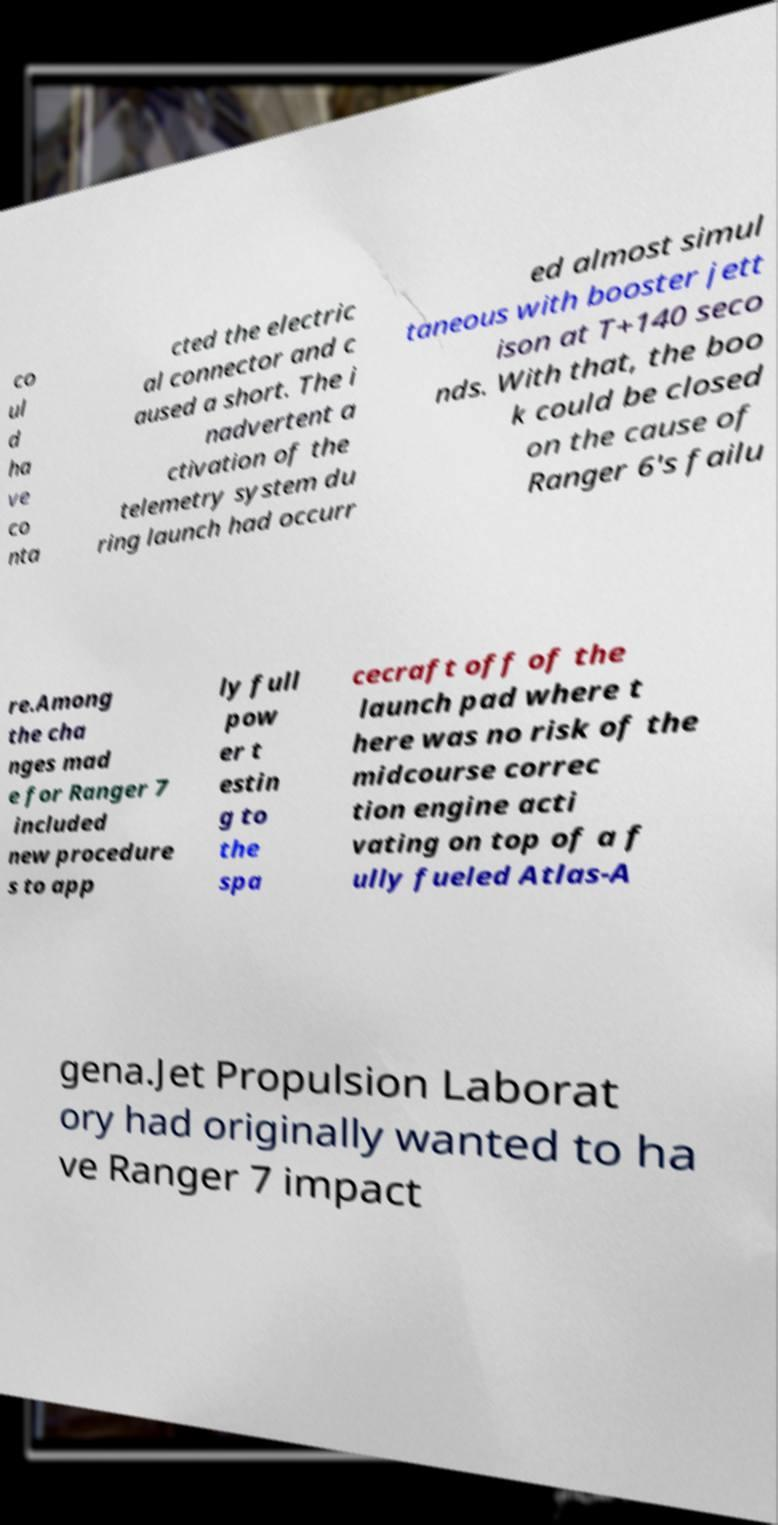Can you accurately transcribe the text from the provided image for me? co ul d ha ve co nta cted the electric al connector and c aused a short. The i nadvertent a ctivation of the telemetry system du ring launch had occurr ed almost simul taneous with booster jett ison at T+140 seco nds. With that, the boo k could be closed on the cause of Ranger 6's failu re.Among the cha nges mad e for Ranger 7 included new procedure s to app ly full pow er t estin g to the spa cecraft off of the launch pad where t here was no risk of the midcourse correc tion engine acti vating on top of a f ully fueled Atlas-A gena.Jet Propulsion Laborat ory had originally wanted to ha ve Ranger 7 impact 